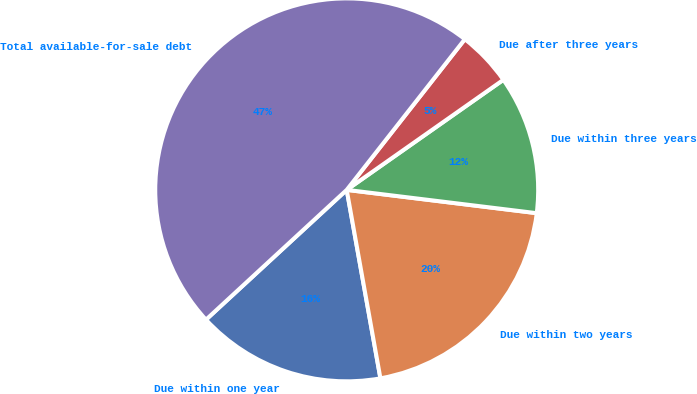Convert chart to OTSL. <chart><loc_0><loc_0><loc_500><loc_500><pie_chart><fcel>Due within one year<fcel>Due within two years<fcel>Due within three years<fcel>Due after three years<fcel>Total available-for-sale debt<nl><fcel>15.96%<fcel>20.24%<fcel>11.69%<fcel>4.67%<fcel>47.44%<nl></chart> 